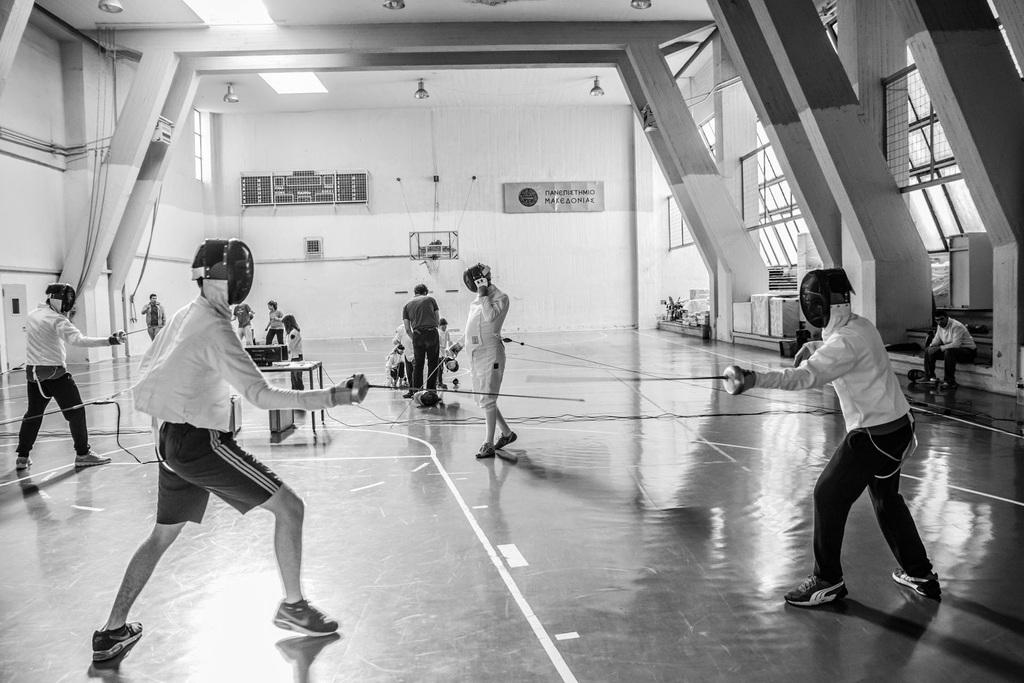What type of location is depicted in the image? The image shows an indoor game hall. What activity are the two people in the front of the image engaged in? They are fighting with swords. What type of architectural feature can be seen in the game hall? There are glass windows visible in the image. What color are the walls in the game hall? The walls in the game hall are white. How many kittens are playing with the sword in the image? There are no kittens present in the image, and they are not playing with the sword. What type of game is being played in the image? The image does not specify the type of game being played, as it only shows two people fighting with swords. 